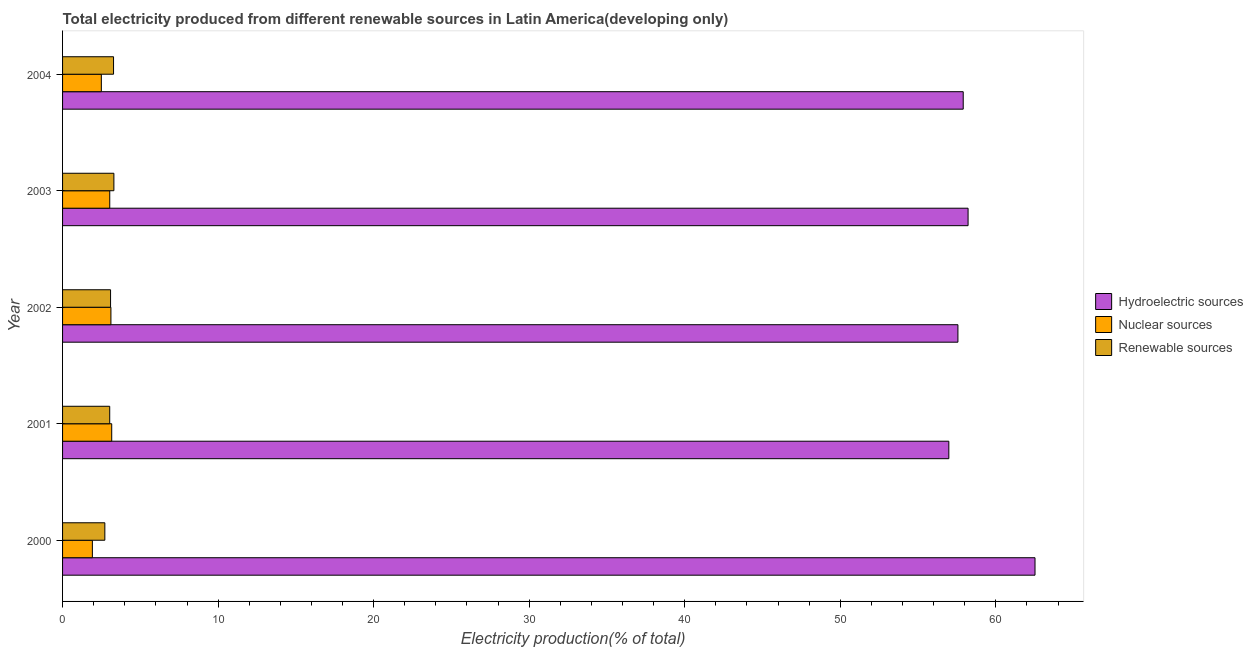How many different coloured bars are there?
Ensure brevity in your answer.  3. How many bars are there on the 1st tick from the top?
Give a very brief answer. 3. How many bars are there on the 2nd tick from the bottom?
Your response must be concise. 3. What is the label of the 1st group of bars from the top?
Keep it short and to the point. 2004. In how many cases, is the number of bars for a given year not equal to the number of legend labels?
Offer a terse response. 0. What is the percentage of electricity produced by nuclear sources in 2004?
Offer a very short reply. 2.49. Across all years, what is the maximum percentage of electricity produced by renewable sources?
Ensure brevity in your answer.  3.3. Across all years, what is the minimum percentage of electricity produced by hydroelectric sources?
Keep it short and to the point. 56.98. In which year was the percentage of electricity produced by nuclear sources maximum?
Keep it short and to the point. 2001. What is the total percentage of electricity produced by hydroelectric sources in the graph?
Provide a succinct answer. 293.19. What is the difference between the percentage of electricity produced by hydroelectric sources in 2001 and that in 2003?
Your response must be concise. -1.24. What is the difference between the percentage of electricity produced by renewable sources in 2003 and the percentage of electricity produced by hydroelectric sources in 2002?
Your answer should be very brief. -54.26. What is the average percentage of electricity produced by nuclear sources per year?
Your answer should be very brief. 2.74. In the year 2000, what is the difference between the percentage of electricity produced by hydroelectric sources and percentage of electricity produced by nuclear sources?
Provide a succinct answer. 60.6. What is the ratio of the percentage of electricity produced by renewable sources in 2000 to that in 2001?
Ensure brevity in your answer.  0.9. Is the difference between the percentage of electricity produced by hydroelectric sources in 2000 and 2002 greater than the difference between the percentage of electricity produced by renewable sources in 2000 and 2002?
Your response must be concise. Yes. What is the difference between the highest and the second highest percentage of electricity produced by renewable sources?
Keep it short and to the point. 0.02. What is the difference between the highest and the lowest percentage of electricity produced by nuclear sources?
Your answer should be compact. 1.24. In how many years, is the percentage of electricity produced by nuclear sources greater than the average percentage of electricity produced by nuclear sources taken over all years?
Ensure brevity in your answer.  3. What does the 1st bar from the top in 2004 represents?
Offer a terse response. Renewable sources. What does the 1st bar from the bottom in 2004 represents?
Your response must be concise. Hydroelectric sources. How many bars are there?
Offer a terse response. 15. Are all the bars in the graph horizontal?
Make the answer very short. Yes. How many years are there in the graph?
Keep it short and to the point. 5. Are the values on the major ticks of X-axis written in scientific E-notation?
Your answer should be compact. No. Does the graph contain grids?
Provide a succinct answer. No. Where does the legend appear in the graph?
Provide a short and direct response. Center right. How many legend labels are there?
Make the answer very short. 3. How are the legend labels stacked?
Your answer should be compact. Vertical. What is the title of the graph?
Your response must be concise. Total electricity produced from different renewable sources in Latin America(developing only). What is the label or title of the X-axis?
Provide a succinct answer. Electricity production(% of total). What is the label or title of the Y-axis?
Ensure brevity in your answer.  Year. What is the Electricity production(% of total) in Hydroelectric sources in 2000?
Your answer should be very brief. 62.52. What is the Electricity production(% of total) in Nuclear sources in 2000?
Give a very brief answer. 1.92. What is the Electricity production(% of total) of Renewable sources in 2000?
Offer a terse response. 2.72. What is the Electricity production(% of total) in Hydroelectric sources in 2001?
Your answer should be very brief. 56.98. What is the Electricity production(% of total) in Nuclear sources in 2001?
Your answer should be compact. 3.16. What is the Electricity production(% of total) in Renewable sources in 2001?
Your response must be concise. 3.03. What is the Electricity production(% of total) of Hydroelectric sources in 2002?
Your answer should be compact. 57.56. What is the Electricity production(% of total) in Nuclear sources in 2002?
Provide a succinct answer. 3.11. What is the Electricity production(% of total) in Renewable sources in 2002?
Keep it short and to the point. 3.09. What is the Electricity production(% of total) in Hydroelectric sources in 2003?
Provide a short and direct response. 58.22. What is the Electricity production(% of total) in Nuclear sources in 2003?
Provide a succinct answer. 3.03. What is the Electricity production(% of total) in Renewable sources in 2003?
Offer a very short reply. 3.3. What is the Electricity production(% of total) of Hydroelectric sources in 2004?
Ensure brevity in your answer.  57.9. What is the Electricity production(% of total) in Nuclear sources in 2004?
Offer a terse response. 2.49. What is the Electricity production(% of total) in Renewable sources in 2004?
Your response must be concise. 3.28. Across all years, what is the maximum Electricity production(% of total) of Hydroelectric sources?
Make the answer very short. 62.52. Across all years, what is the maximum Electricity production(% of total) of Nuclear sources?
Provide a succinct answer. 3.16. Across all years, what is the maximum Electricity production(% of total) of Renewable sources?
Offer a terse response. 3.3. Across all years, what is the minimum Electricity production(% of total) of Hydroelectric sources?
Make the answer very short. 56.98. Across all years, what is the minimum Electricity production(% of total) of Nuclear sources?
Your answer should be compact. 1.92. Across all years, what is the minimum Electricity production(% of total) in Renewable sources?
Make the answer very short. 2.72. What is the total Electricity production(% of total) of Hydroelectric sources in the graph?
Make the answer very short. 293.19. What is the total Electricity production(% of total) in Nuclear sources in the graph?
Make the answer very short. 13.71. What is the total Electricity production(% of total) in Renewable sources in the graph?
Give a very brief answer. 15.41. What is the difference between the Electricity production(% of total) in Hydroelectric sources in 2000 and that in 2001?
Offer a terse response. 5.54. What is the difference between the Electricity production(% of total) in Nuclear sources in 2000 and that in 2001?
Keep it short and to the point. -1.24. What is the difference between the Electricity production(% of total) of Renewable sources in 2000 and that in 2001?
Keep it short and to the point. -0.31. What is the difference between the Electricity production(% of total) of Hydroelectric sources in 2000 and that in 2002?
Your answer should be very brief. 4.96. What is the difference between the Electricity production(% of total) of Nuclear sources in 2000 and that in 2002?
Make the answer very short. -1.19. What is the difference between the Electricity production(% of total) in Renewable sources in 2000 and that in 2002?
Provide a succinct answer. -0.37. What is the difference between the Electricity production(% of total) in Hydroelectric sources in 2000 and that in 2003?
Offer a terse response. 4.3. What is the difference between the Electricity production(% of total) in Nuclear sources in 2000 and that in 2003?
Your answer should be very brief. -1.12. What is the difference between the Electricity production(% of total) of Renewable sources in 2000 and that in 2003?
Make the answer very short. -0.58. What is the difference between the Electricity production(% of total) in Hydroelectric sources in 2000 and that in 2004?
Give a very brief answer. 4.62. What is the difference between the Electricity production(% of total) of Nuclear sources in 2000 and that in 2004?
Give a very brief answer. -0.58. What is the difference between the Electricity production(% of total) in Renewable sources in 2000 and that in 2004?
Make the answer very short. -0.56. What is the difference between the Electricity production(% of total) of Hydroelectric sources in 2001 and that in 2002?
Offer a very short reply. -0.58. What is the difference between the Electricity production(% of total) in Nuclear sources in 2001 and that in 2002?
Provide a succinct answer. 0.05. What is the difference between the Electricity production(% of total) of Renewable sources in 2001 and that in 2002?
Provide a succinct answer. -0.05. What is the difference between the Electricity production(% of total) in Hydroelectric sources in 2001 and that in 2003?
Make the answer very short. -1.24. What is the difference between the Electricity production(% of total) of Nuclear sources in 2001 and that in 2003?
Offer a terse response. 0.13. What is the difference between the Electricity production(% of total) in Renewable sources in 2001 and that in 2003?
Offer a terse response. -0.27. What is the difference between the Electricity production(% of total) of Hydroelectric sources in 2001 and that in 2004?
Give a very brief answer. -0.92. What is the difference between the Electricity production(% of total) in Nuclear sources in 2001 and that in 2004?
Your answer should be compact. 0.67. What is the difference between the Electricity production(% of total) of Renewable sources in 2001 and that in 2004?
Offer a terse response. -0.25. What is the difference between the Electricity production(% of total) in Hydroelectric sources in 2002 and that in 2003?
Keep it short and to the point. -0.65. What is the difference between the Electricity production(% of total) in Nuclear sources in 2002 and that in 2003?
Offer a very short reply. 0.07. What is the difference between the Electricity production(% of total) in Renewable sources in 2002 and that in 2003?
Keep it short and to the point. -0.21. What is the difference between the Electricity production(% of total) of Hydroelectric sources in 2002 and that in 2004?
Your response must be concise. -0.34. What is the difference between the Electricity production(% of total) of Nuclear sources in 2002 and that in 2004?
Provide a short and direct response. 0.62. What is the difference between the Electricity production(% of total) of Renewable sources in 2002 and that in 2004?
Ensure brevity in your answer.  -0.19. What is the difference between the Electricity production(% of total) of Hydroelectric sources in 2003 and that in 2004?
Ensure brevity in your answer.  0.31. What is the difference between the Electricity production(% of total) of Nuclear sources in 2003 and that in 2004?
Ensure brevity in your answer.  0.54. What is the difference between the Electricity production(% of total) in Renewable sources in 2003 and that in 2004?
Your answer should be compact. 0.02. What is the difference between the Electricity production(% of total) in Hydroelectric sources in 2000 and the Electricity production(% of total) in Nuclear sources in 2001?
Keep it short and to the point. 59.36. What is the difference between the Electricity production(% of total) of Hydroelectric sources in 2000 and the Electricity production(% of total) of Renewable sources in 2001?
Provide a short and direct response. 59.49. What is the difference between the Electricity production(% of total) of Nuclear sources in 2000 and the Electricity production(% of total) of Renewable sources in 2001?
Give a very brief answer. -1.11. What is the difference between the Electricity production(% of total) in Hydroelectric sources in 2000 and the Electricity production(% of total) in Nuclear sources in 2002?
Keep it short and to the point. 59.41. What is the difference between the Electricity production(% of total) in Hydroelectric sources in 2000 and the Electricity production(% of total) in Renewable sources in 2002?
Make the answer very short. 59.43. What is the difference between the Electricity production(% of total) of Nuclear sources in 2000 and the Electricity production(% of total) of Renewable sources in 2002?
Your response must be concise. -1.17. What is the difference between the Electricity production(% of total) in Hydroelectric sources in 2000 and the Electricity production(% of total) in Nuclear sources in 2003?
Offer a very short reply. 59.49. What is the difference between the Electricity production(% of total) of Hydroelectric sources in 2000 and the Electricity production(% of total) of Renewable sources in 2003?
Offer a terse response. 59.22. What is the difference between the Electricity production(% of total) in Nuclear sources in 2000 and the Electricity production(% of total) in Renewable sources in 2003?
Provide a succinct answer. -1.38. What is the difference between the Electricity production(% of total) in Hydroelectric sources in 2000 and the Electricity production(% of total) in Nuclear sources in 2004?
Provide a short and direct response. 60.03. What is the difference between the Electricity production(% of total) of Hydroelectric sources in 2000 and the Electricity production(% of total) of Renewable sources in 2004?
Your response must be concise. 59.24. What is the difference between the Electricity production(% of total) of Nuclear sources in 2000 and the Electricity production(% of total) of Renewable sources in 2004?
Keep it short and to the point. -1.36. What is the difference between the Electricity production(% of total) of Hydroelectric sources in 2001 and the Electricity production(% of total) of Nuclear sources in 2002?
Give a very brief answer. 53.87. What is the difference between the Electricity production(% of total) in Hydroelectric sources in 2001 and the Electricity production(% of total) in Renewable sources in 2002?
Keep it short and to the point. 53.89. What is the difference between the Electricity production(% of total) of Nuclear sources in 2001 and the Electricity production(% of total) of Renewable sources in 2002?
Offer a very short reply. 0.07. What is the difference between the Electricity production(% of total) of Hydroelectric sources in 2001 and the Electricity production(% of total) of Nuclear sources in 2003?
Your answer should be compact. 53.95. What is the difference between the Electricity production(% of total) of Hydroelectric sources in 2001 and the Electricity production(% of total) of Renewable sources in 2003?
Your response must be concise. 53.68. What is the difference between the Electricity production(% of total) in Nuclear sources in 2001 and the Electricity production(% of total) in Renewable sources in 2003?
Offer a very short reply. -0.14. What is the difference between the Electricity production(% of total) in Hydroelectric sources in 2001 and the Electricity production(% of total) in Nuclear sources in 2004?
Your response must be concise. 54.49. What is the difference between the Electricity production(% of total) in Hydroelectric sources in 2001 and the Electricity production(% of total) in Renewable sources in 2004?
Ensure brevity in your answer.  53.7. What is the difference between the Electricity production(% of total) in Nuclear sources in 2001 and the Electricity production(% of total) in Renewable sources in 2004?
Your response must be concise. -0.12. What is the difference between the Electricity production(% of total) in Hydroelectric sources in 2002 and the Electricity production(% of total) in Nuclear sources in 2003?
Your response must be concise. 54.53. What is the difference between the Electricity production(% of total) in Hydroelectric sources in 2002 and the Electricity production(% of total) in Renewable sources in 2003?
Keep it short and to the point. 54.26. What is the difference between the Electricity production(% of total) of Nuclear sources in 2002 and the Electricity production(% of total) of Renewable sources in 2003?
Provide a short and direct response. -0.19. What is the difference between the Electricity production(% of total) in Hydroelectric sources in 2002 and the Electricity production(% of total) in Nuclear sources in 2004?
Make the answer very short. 55.07. What is the difference between the Electricity production(% of total) in Hydroelectric sources in 2002 and the Electricity production(% of total) in Renewable sources in 2004?
Provide a succinct answer. 54.29. What is the difference between the Electricity production(% of total) in Nuclear sources in 2002 and the Electricity production(% of total) in Renewable sources in 2004?
Your answer should be compact. -0.17. What is the difference between the Electricity production(% of total) of Hydroelectric sources in 2003 and the Electricity production(% of total) of Nuclear sources in 2004?
Give a very brief answer. 55.72. What is the difference between the Electricity production(% of total) of Hydroelectric sources in 2003 and the Electricity production(% of total) of Renewable sources in 2004?
Ensure brevity in your answer.  54.94. What is the difference between the Electricity production(% of total) in Nuclear sources in 2003 and the Electricity production(% of total) in Renewable sources in 2004?
Ensure brevity in your answer.  -0.24. What is the average Electricity production(% of total) in Hydroelectric sources per year?
Your answer should be very brief. 58.64. What is the average Electricity production(% of total) in Nuclear sources per year?
Keep it short and to the point. 2.74. What is the average Electricity production(% of total) in Renewable sources per year?
Your response must be concise. 3.08. In the year 2000, what is the difference between the Electricity production(% of total) of Hydroelectric sources and Electricity production(% of total) of Nuclear sources?
Your answer should be very brief. 60.6. In the year 2000, what is the difference between the Electricity production(% of total) of Hydroelectric sources and Electricity production(% of total) of Renewable sources?
Keep it short and to the point. 59.8. In the year 2000, what is the difference between the Electricity production(% of total) in Nuclear sources and Electricity production(% of total) in Renewable sources?
Give a very brief answer. -0.8. In the year 2001, what is the difference between the Electricity production(% of total) in Hydroelectric sources and Electricity production(% of total) in Nuclear sources?
Provide a short and direct response. 53.82. In the year 2001, what is the difference between the Electricity production(% of total) in Hydroelectric sources and Electricity production(% of total) in Renewable sources?
Keep it short and to the point. 53.95. In the year 2001, what is the difference between the Electricity production(% of total) of Nuclear sources and Electricity production(% of total) of Renewable sources?
Your answer should be compact. 0.13. In the year 2002, what is the difference between the Electricity production(% of total) in Hydroelectric sources and Electricity production(% of total) in Nuclear sources?
Ensure brevity in your answer.  54.46. In the year 2002, what is the difference between the Electricity production(% of total) of Hydroelectric sources and Electricity production(% of total) of Renewable sources?
Give a very brief answer. 54.48. In the year 2002, what is the difference between the Electricity production(% of total) of Nuclear sources and Electricity production(% of total) of Renewable sources?
Make the answer very short. 0.02. In the year 2003, what is the difference between the Electricity production(% of total) of Hydroelectric sources and Electricity production(% of total) of Nuclear sources?
Offer a terse response. 55.18. In the year 2003, what is the difference between the Electricity production(% of total) of Hydroelectric sources and Electricity production(% of total) of Renewable sources?
Your response must be concise. 54.92. In the year 2003, what is the difference between the Electricity production(% of total) of Nuclear sources and Electricity production(% of total) of Renewable sources?
Provide a short and direct response. -0.27. In the year 2004, what is the difference between the Electricity production(% of total) in Hydroelectric sources and Electricity production(% of total) in Nuclear sources?
Offer a terse response. 55.41. In the year 2004, what is the difference between the Electricity production(% of total) of Hydroelectric sources and Electricity production(% of total) of Renewable sources?
Your answer should be very brief. 54.63. In the year 2004, what is the difference between the Electricity production(% of total) in Nuclear sources and Electricity production(% of total) in Renewable sources?
Offer a terse response. -0.79. What is the ratio of the Electricity production(% of total) in Hydroelectric sources in 2000 to that in 2001?
Provide a short and direct response. 1.1. What is the ratio of the Electricity production(% of total) in Nuclear sources in 2000 to that in 2001?
Provide a short and direct response. 0.61. What is the ratio of the Electricity production(% of total) in Renewable sources in 2000 to that in 2001?
Make the answer very short. 0.9. What is the ratio of the Electricity production(% of total) of Hydroelectric sources in 2000 to that in 2002?
Ensure brevity in your answer.  1.09. What is the ratio of the Electricity production(% of total) in Nuclear sources in 2000 to that in 2002?
Give a very brief answer. 0.62. What is the ratio of the Electricity production(% of total) of Renewable sources in 2000 to that in 2002?
Offer a very short reply. 0.88. What is the ratio of the Electricity production(% of total) in Hydroelectric sources in 2000 to that in 2003?
Ensure brevity in your answer.  1.07. What is the ratio of the Electricity production(% of total) in Nuclear sources in 2000 to that in 2003?
Ensure brevity in your answer.  0.63. What is the ratio of the Electricity production(% of total) of Renewable sources in 2000 to that in 2003?
Give a very brief answer. 0.82. What is the ratio of the Electricity production(% of total) in Hydroelectric sources in 2000 to that in 2004?
Ensure brevity in your answer.  1.08. What is the ratio of the Electricity production(% of total) in Nuclear sources in 2000 to that in 2004?
Ensure brevity in your answer.  0.77. What is the ratio of the Electricity production(% of total) of Renewable sources in 2000 to that in 2004?
Keep it short and to the point. 0.83. What is the ratio of the Electricity production(% of total) in Hydroelectric sources in 2001 to that in 2002?
Provide a succinct answer. 0.99. What is the ratio of the Electricity production(% of total) in Nuclear sources in 2001 to that in 2002?
Your answer should be very brief. 1.02. What is the ratio of the Electricity production(% of total) of Renewable sources in 2001 to that in 2002?
Ensure brevity in your answer.  0.98. What is the ratio of the Electricity production(% of total) of Hydroelectric sources in 2001 to that in 2003?
Offer a terse response. 0.98. What is the ratio of the Electricity production(% of total) in Nuclear sources in 2001 to that in 2003?
Give a very brief answer. 1.04. What is the ratio of the Electricity production(% of total) of Renewable sources in 2001 to that in 2003?
Offer a terse response. 0.92. What is the ratio of the Electricity production(% of total) of Nuclear sources in 2001 to that in 2004?
Your answer should be very brief. 1.27. What is the ratio of the Electricity production(% of total) of Renewable sources in 2001 to that in 2004?
Provide a short and direct response. 0.92. What is the ratio of the Electricity production(% of total) of Hydroelectric sources in 2002 to that in 2003?
Give a very brief answer. 0.99. What is the ratio of the Electricity production(% of total) in Nuclear sources in 2002 to that in 2003?
Make the answer very short. 1.02. What is the ratio of the Electricity production(% of total) in Renewable sources in 2002 to that in 2003?
Your answer should be compact. 0.94. What is the ratio of the Electricity production(% of total) in Nuclear sources in 2002 to that in 2004?
Your response must be concise. 1.25. What is the ratio of the Electricity production(% of total) of Renewable sources in 2002 to that in 2004?
Provide a short and direct response. 0.94. What is the ratio of the Electricity production(% of total) in Hydroelectric sources in 2003 to that in 2004?
Offer a terse response. 1.01. What is the ratio of the Electricity production(% of total) in Nuclear sources in 2003 to that in 2004?
Keep it short and to the point. 1.22. What is the ratio of the Electricity production(% of total) in Renewable sources in 2003 to that in 2004?
Give a very brief answer. 1.01. What is the difference between the highest and the second highest Electricity production(% of total) of Hydroelectric sources?
Ensure brevity in your answer.  4.3. What is the difference between the highest and the second highest Electricity production(% of total) in Nuclear sources?
Offer a terse response. 0.05. What is the difference between the highest and the second highest Electricity production(% of total) of Renewable sources?
Your answer should be compact. 0.02. What is the difference between the highest and the lowest Electricity production(% of total) in Hydroelectric sources?
Provide a succinct answer. 5.54. What is the difference between the highest and the lowest Electricity production(% of total) of Nuclear sources?
Offer a very short reply. 1.24. What is the difference between the highest and the lowest Electricity production(% of total) in Renewable sources?
Offer a very short reply. 0.58. 